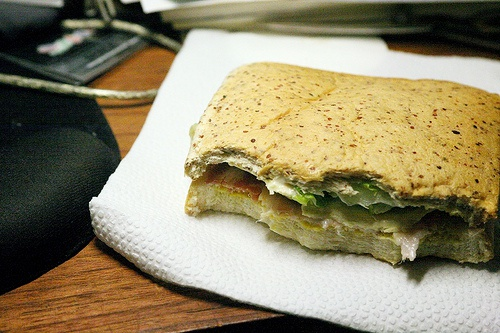Describe the objects in this image and their specific colors. I can see a sandwich in gray, khaki, tan, black, and olive tones in this image. 